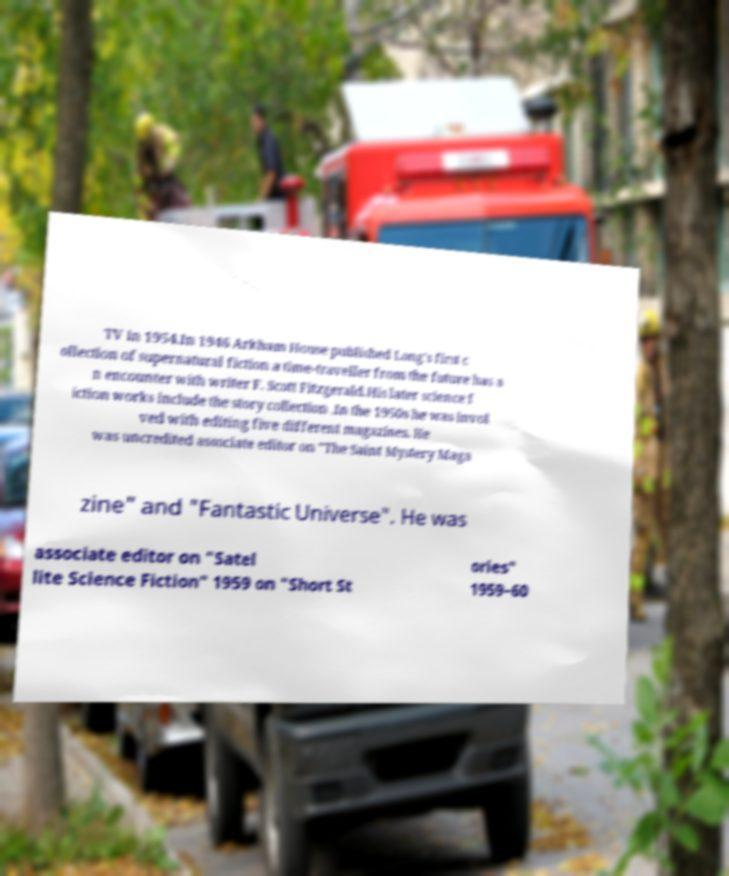For documentation purposes, I need the text within this image transcribed. Could you provide that? TV in 1954.In 1946 Arkham House published Long's first c ollection of supernatural fiction a time-traveller from the future has a n encounter with writer F. Scott Fitzgerald.His later science f iction works include the story collection .In the 1950s he was invol ved with editing five different magazines. He was uncredited associate editor on "The Saint Mystery Maga zine" and "Fantastic Universe". He was associate editor on "Satel lite Science Fiction" 1959 on "Short St ories" 1959–60 